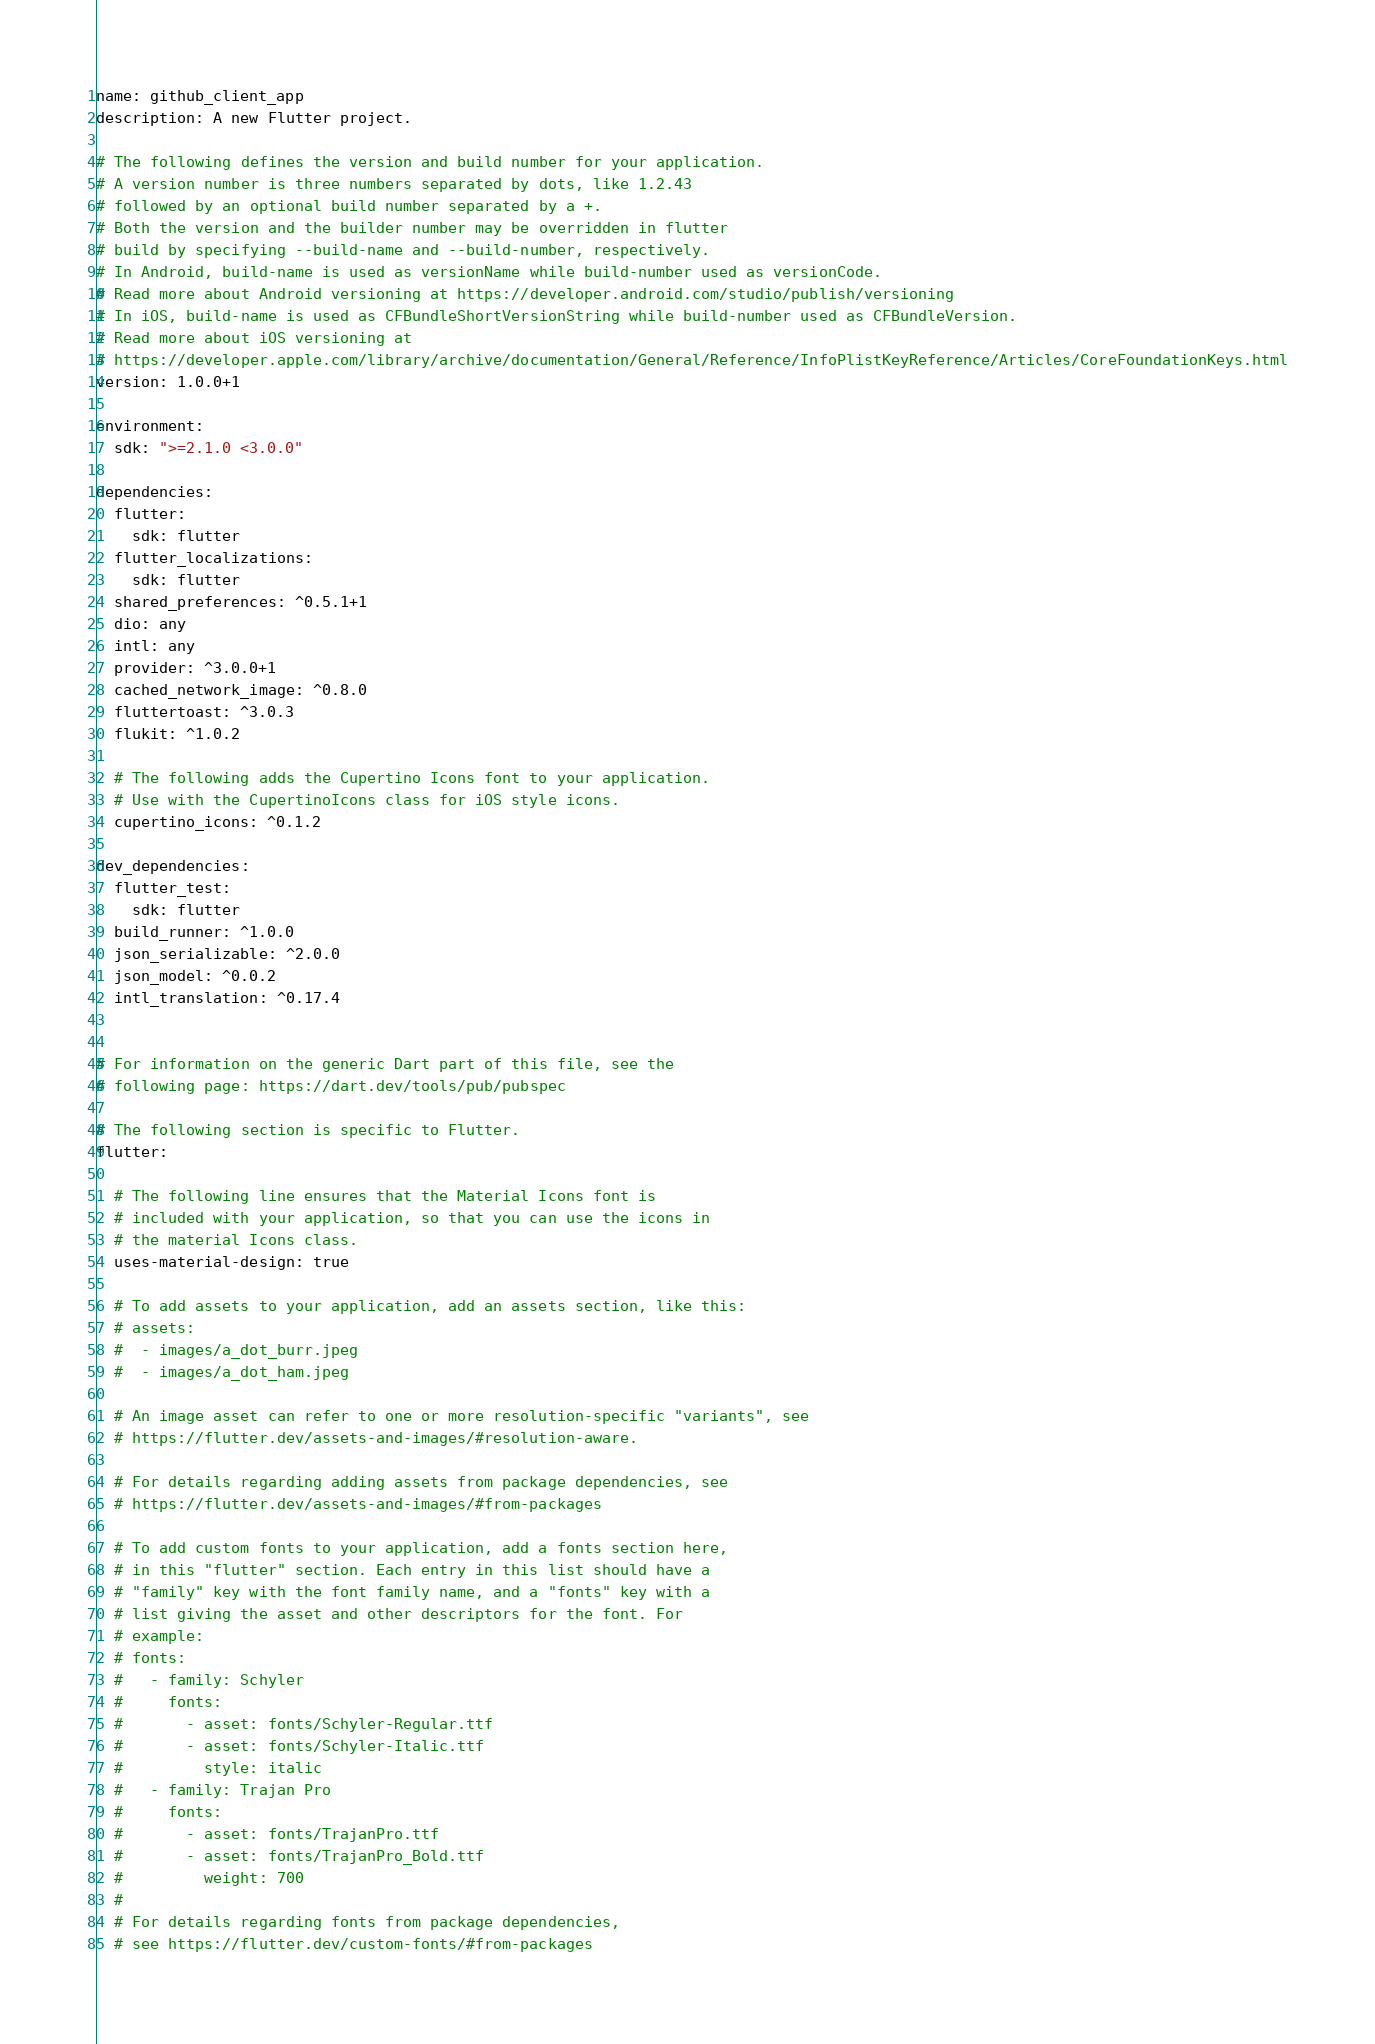Convert code to text. <code><loc_0><loc_0><loc_500><loc_500><_YAML_>name: github_client_app
description: A new Flutter project.

# The following defines the version and build number for your application.
# A version number is three numbers separated by dots, like 1.2.43
# followed by an optional build number separated by a +.
# Both the version and the builder number may be overridden in flutter
# build by specifying --build-name and --build-number, respectively.
# In Android, build-name is used as versionName while build-number used as versionCode.
# Read more about Android versioning at https://developer.android.com/studio/publish/versioning
# In iOS, build-name is used as CFBundleShortVersionString while build-number used as CFBundleVersion.
# Read more about iOS versioning at
# https://developer.apple.com/library/archive/documentation/General/Reference/InfoPlistKeyReference/Articles/CoreFoundationKeys.html
version: 1.0.0+1

environment:
  sdk: ">=2.1.0 <3.0.0"

dependencies:
  flutter:
    sdk: flutter
  flutter_localizations:
    sdk: flutter
  shared_preferences: ^0.5.1+1
  dio: any
  intl: any
  provider: ^3.0.0+1
  cached_network_image: ^0.8.0
  fluttertoast: ^3.0.3
  flukit: ^1.0.2

  # The following adds the Cupertino Icons font to your application.
  # Use with the CupertinoIcons class for iOS style icons.
  cupertino_icons: ^0.1.2

dev_dependencies:
  flutter_test:
    sdk: flutter
  build_runner: ^1.0.0
  json_serializable: ^2.0.0
  json_model: ^0.0.2
  intl_translation: ^0.17.4


# For information on the generic Dart part of this file, see the
# following page: https://dart.dev/tools/pub/pubspec

# The following section is specific to Flutter.
flutter:

  # The following line ensures that the Material Icons font is
  # included with your application, so that you can use the icons in
  # the material Icons class.
  uses-material-design: true

  # To add assets to your application, add an assets section, like this:
  # assets:
  #  - images/a_dot_burr.jpeg
  #  - images/a_dot_ham.jpeg

  # An image asset can refer to one or more resolution-specific "variants", see
  # https://flutter.dev/assets-and-images/#resolution-aware.

  # For details regarding adding assets from package dependencies, see
  # https://flutter.dev/assets-and-images/#from-packages

  # To add custom fonts to your application, add a fonts section here,
  # in this "flutter" section. Each entry in this list should have a
  # "family" key with the font family name, and a "fonts" key with a
  # list giving the asset and other descriptors for the font. For
  # example:
  # fonts:
  #   - family: Schyler
  #     fonts:
  #       - asset: fonts/Schyler-Regular.ttf
  #       - asset: fonts/Schyler-Italic.ttf
  #         style: italic
  #   - family: Trajan Pro
  #     fonts:
  #       - asset: fonts/TrajanPro.ttf
  #       - asset: fonts/TrajanPro_Bold.ttf
  #         weight: 700
  #
  # For details regarding fonts from package dependencies,
  # see https://flutter.dev/custom-fonts/#from-packages
</code> 